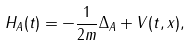<formula> <loc_0><loc_0><loc_500><loc_500>H _ { A } ( t ) = - \frac { 1 } { 2 m } \Delta _ { A } + V ( t , x ) ,</formula> 